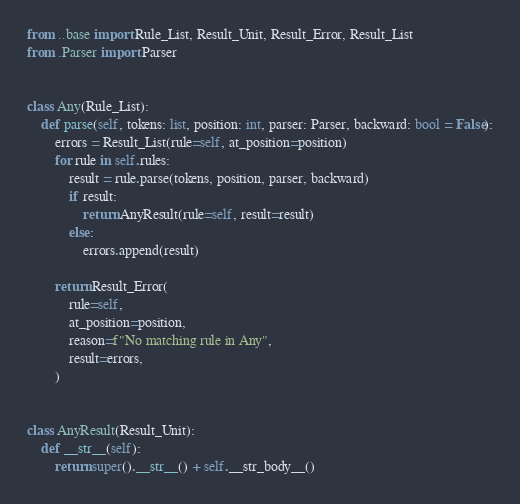Convert code to text. <code><loc_0><loc_0><loc_500><loc_500><_Python_>from ..base import Rule_List, Result_Unit, Result_Error, Result_List
from .Parser import Parser


class Any(Rule_List):
    def parse(self, tokens: list, position: int, parser: Parser, backward: bool = False):
        errors = Result_List(rule=self, at_position=position)
        for rule in self.rules:
            result = rule.parse(tokens, position, parser, backward)
            if result:
                return AnyResult(rule=self, result=result)
            else:
                errors.append(result)

        return Result_Error(
            rule=self,
            at_position=position,
            reason=f"No matching rule in Any",
            result=errors,
        )


class AnyResult(Result_Unit):
    def __str__(self):
        return super().__str__() + self.__str_body__()
</code> 